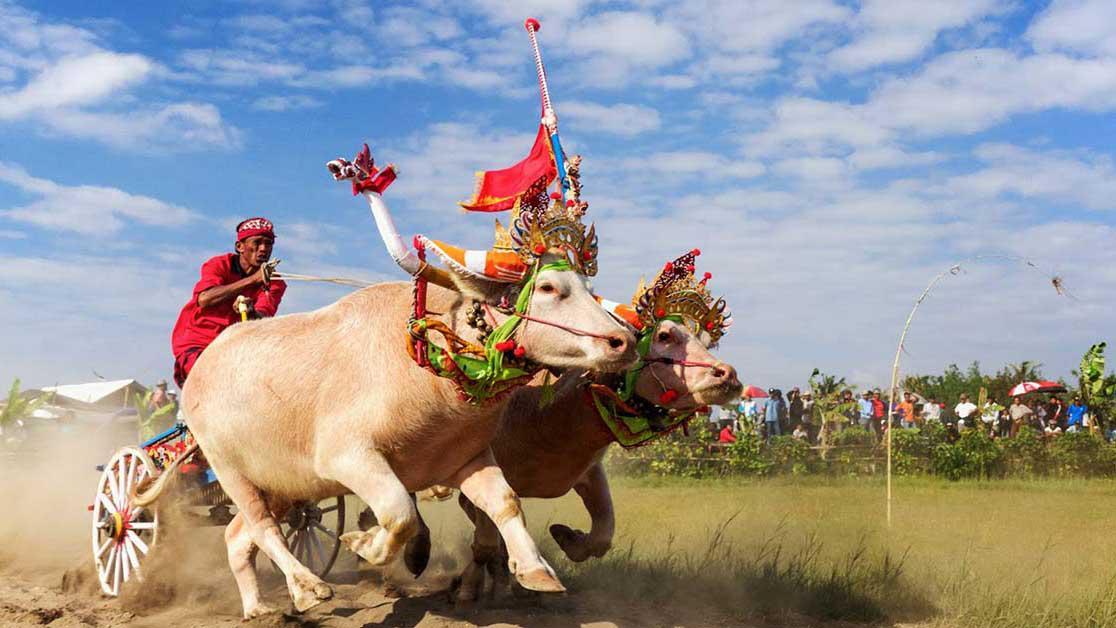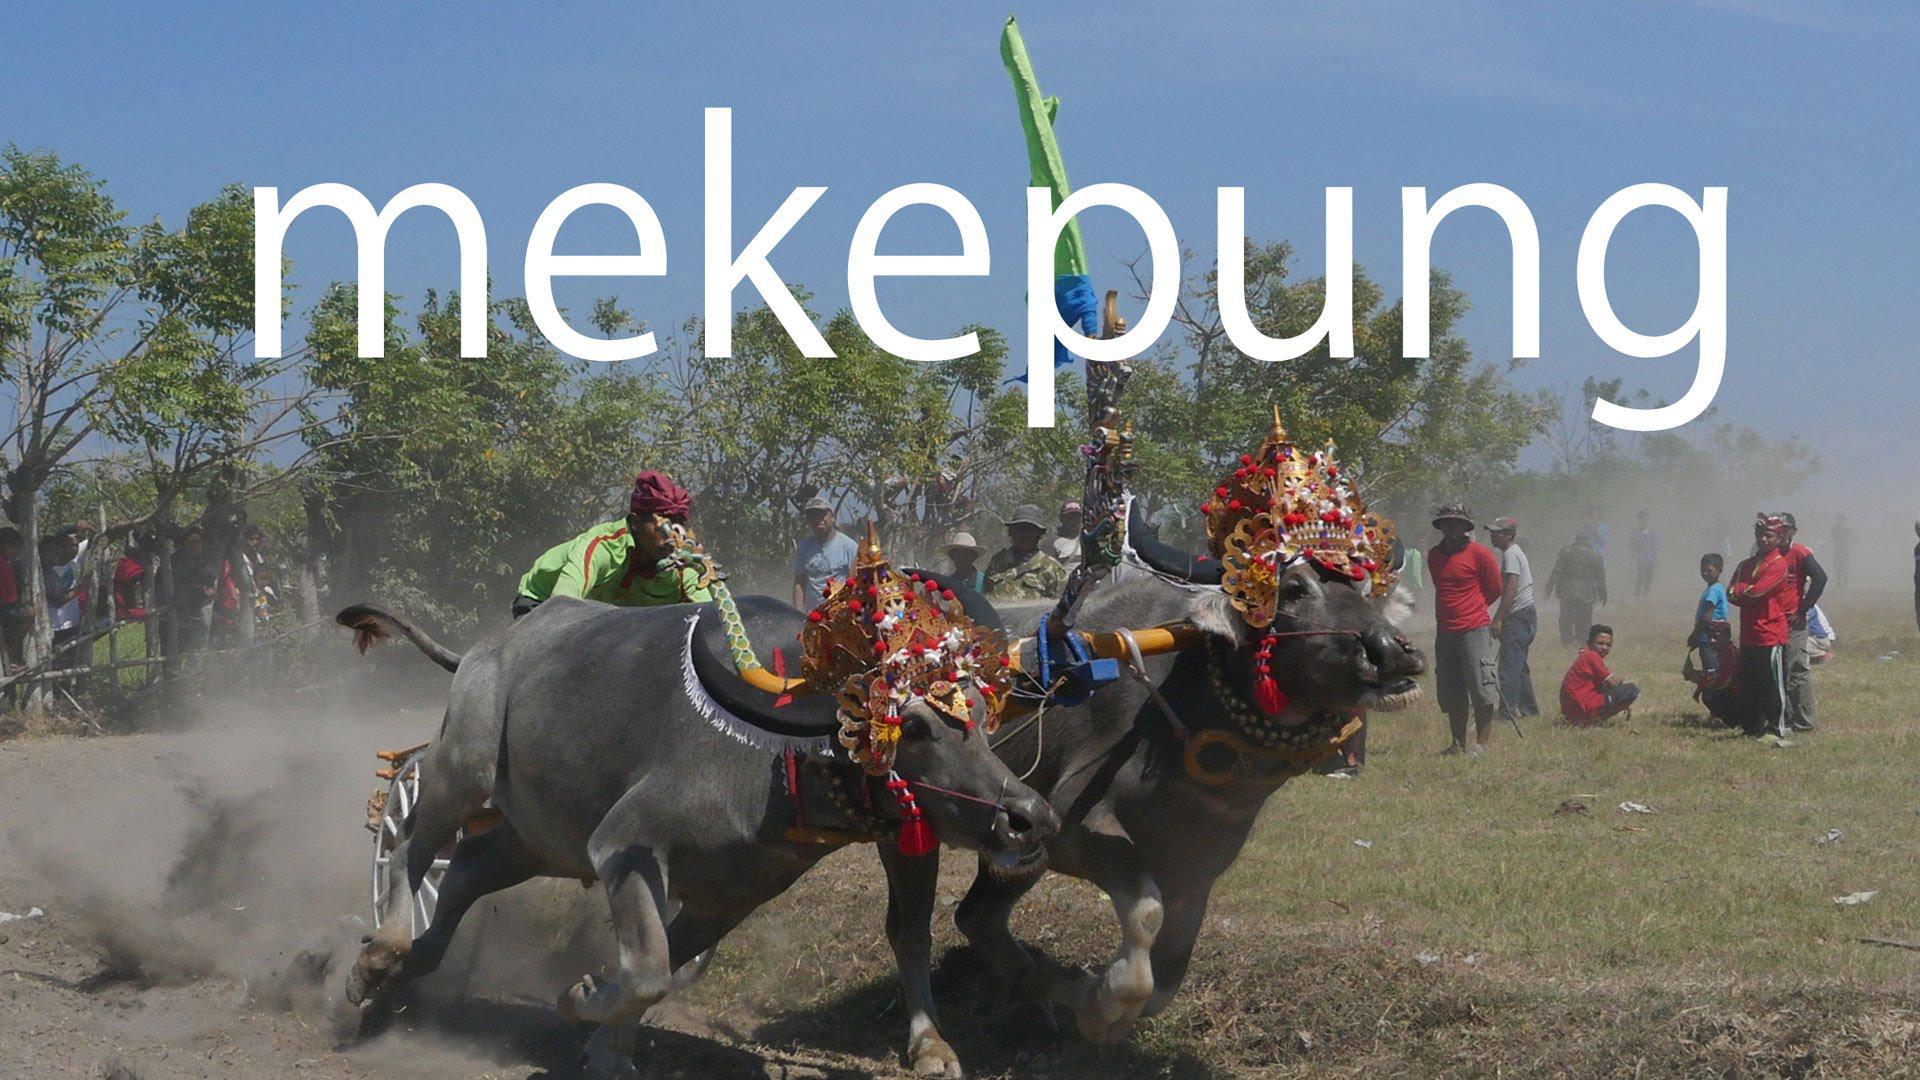The first image is the image on the left, the second image is the image on the right. Examine the images to the left and right. Is the description "In the right image, two ox-cart racers in green shirts are driving teams of two non-black oxen to the right." accurate? Answer yes or no. No. 